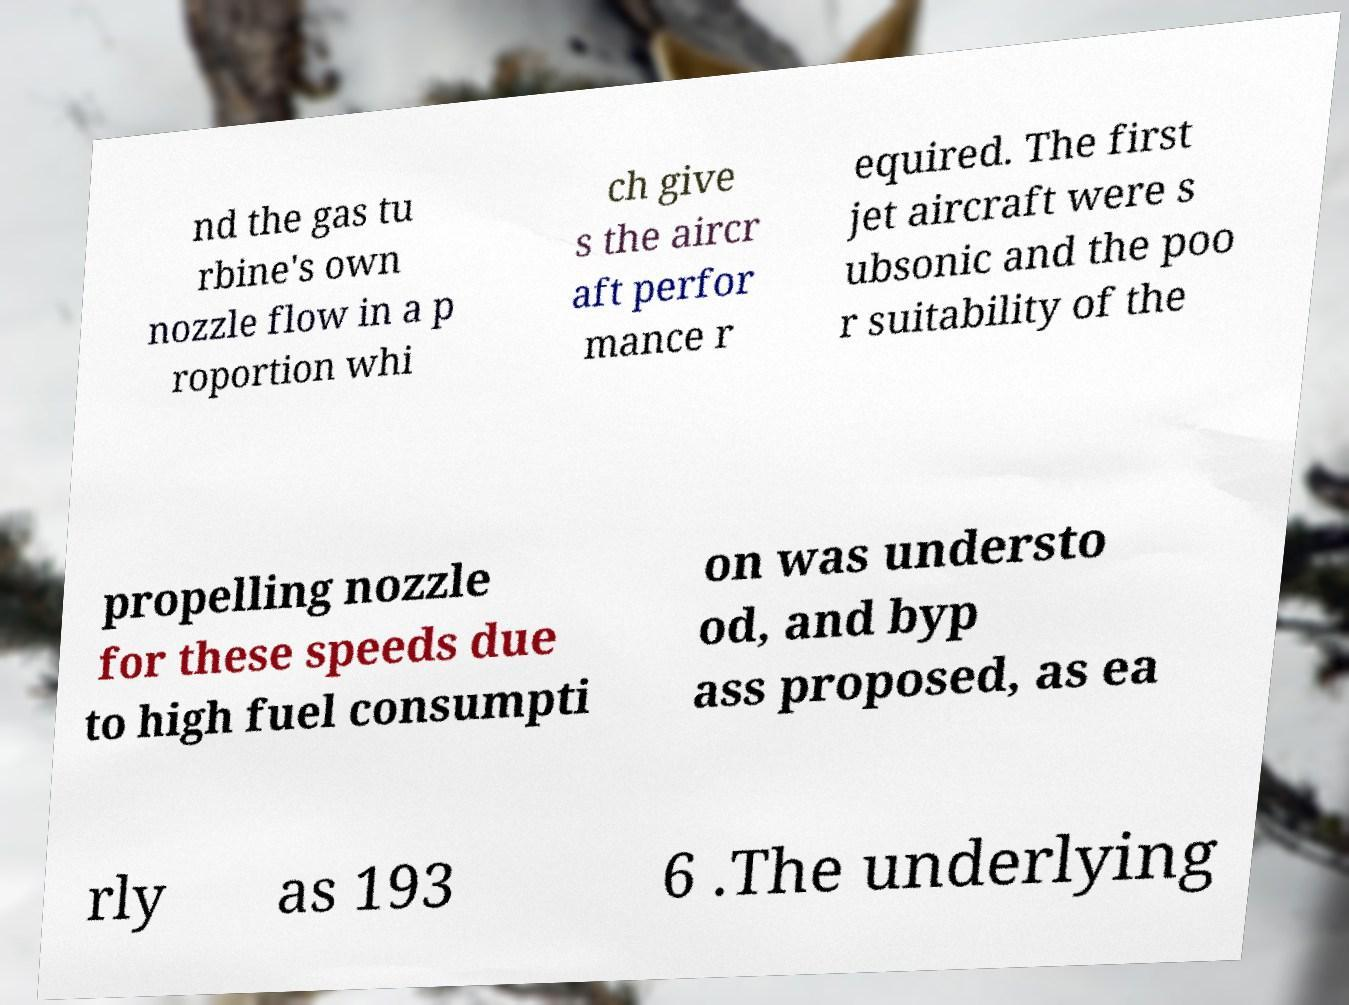What messages or text are displayed in this image? I need them in a readable, typed format. nd the gas tu rbine's own nozzle flow in a p roportion whi ch give s the aircr aft perfor mance r equired. The first jet aircraft were s ubsonic and the poo r suitability of the propelling nozzle for these speeds due to high fuel consumpti on was understo od, and byp ass proposed, as ea rly as 193 6 .The underlying 